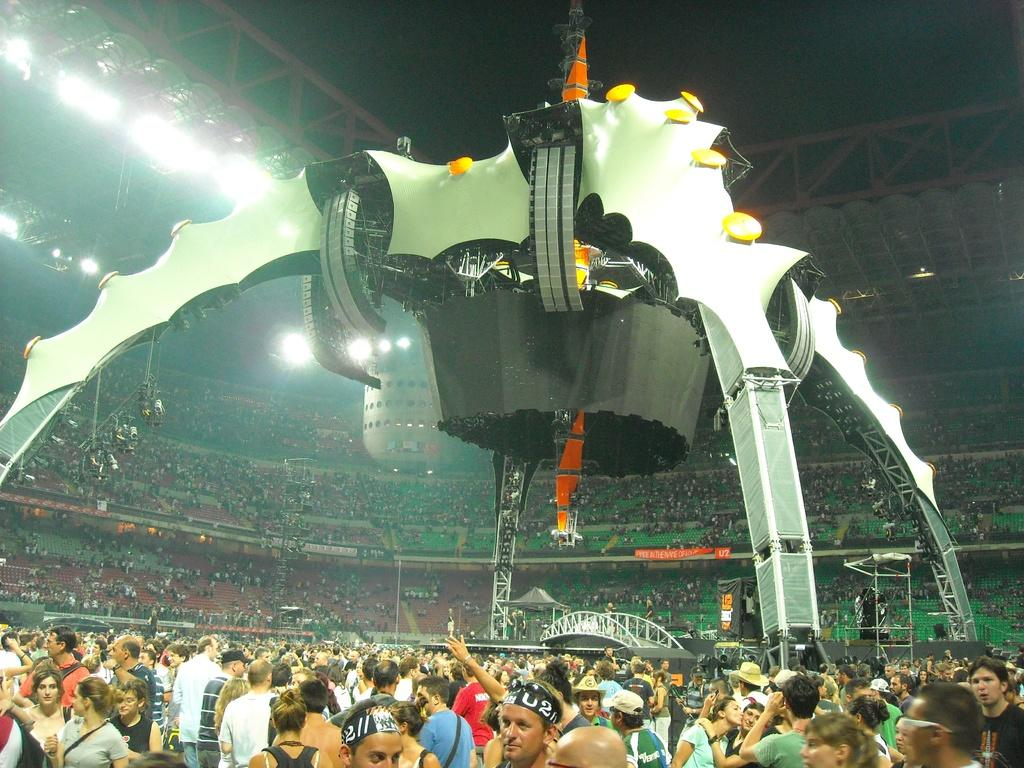How many people are in the group visible in the image? There is a group of people standing in the image, but the exact number cannot be determined from the provided facts. What is the main feature of the image? The main feature of the image is a stage. What can be seen in the background of the image? There are lights and other objects visible in the background of the image. What type of meat is being cooked on the wing in the image? There is no wing or meat present in the image. How many frogs are visible on the stage in the image? There are no frogs visible on the stage or anywhere else in the image. 